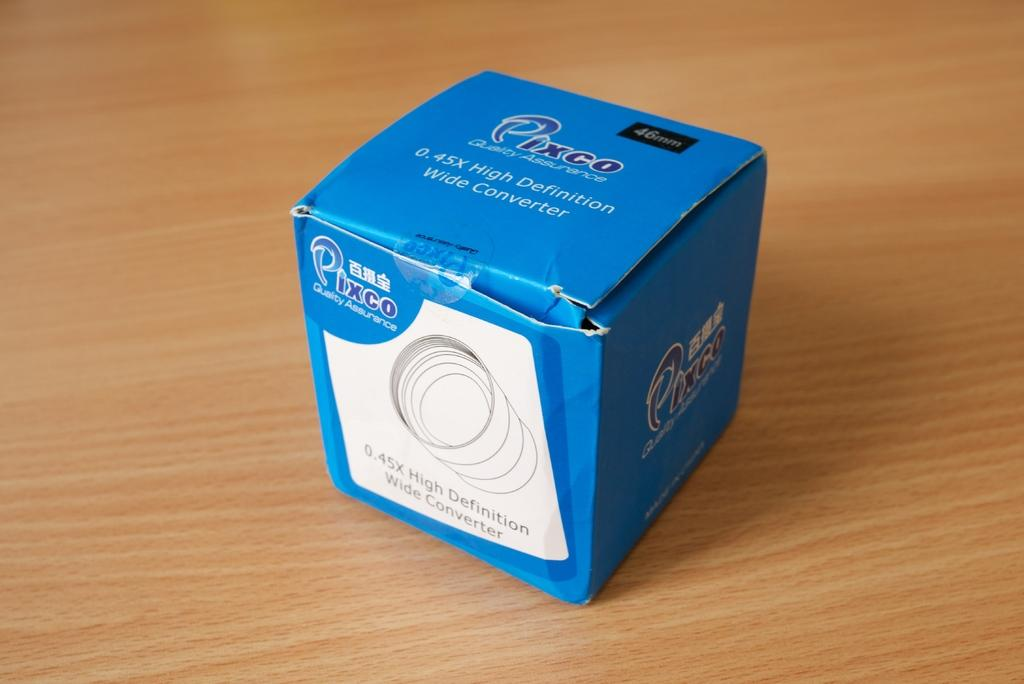<image>
Present a compact description of the photo's key features. A blue and white box that is from the company Pixco contains a high definition wide converter. 